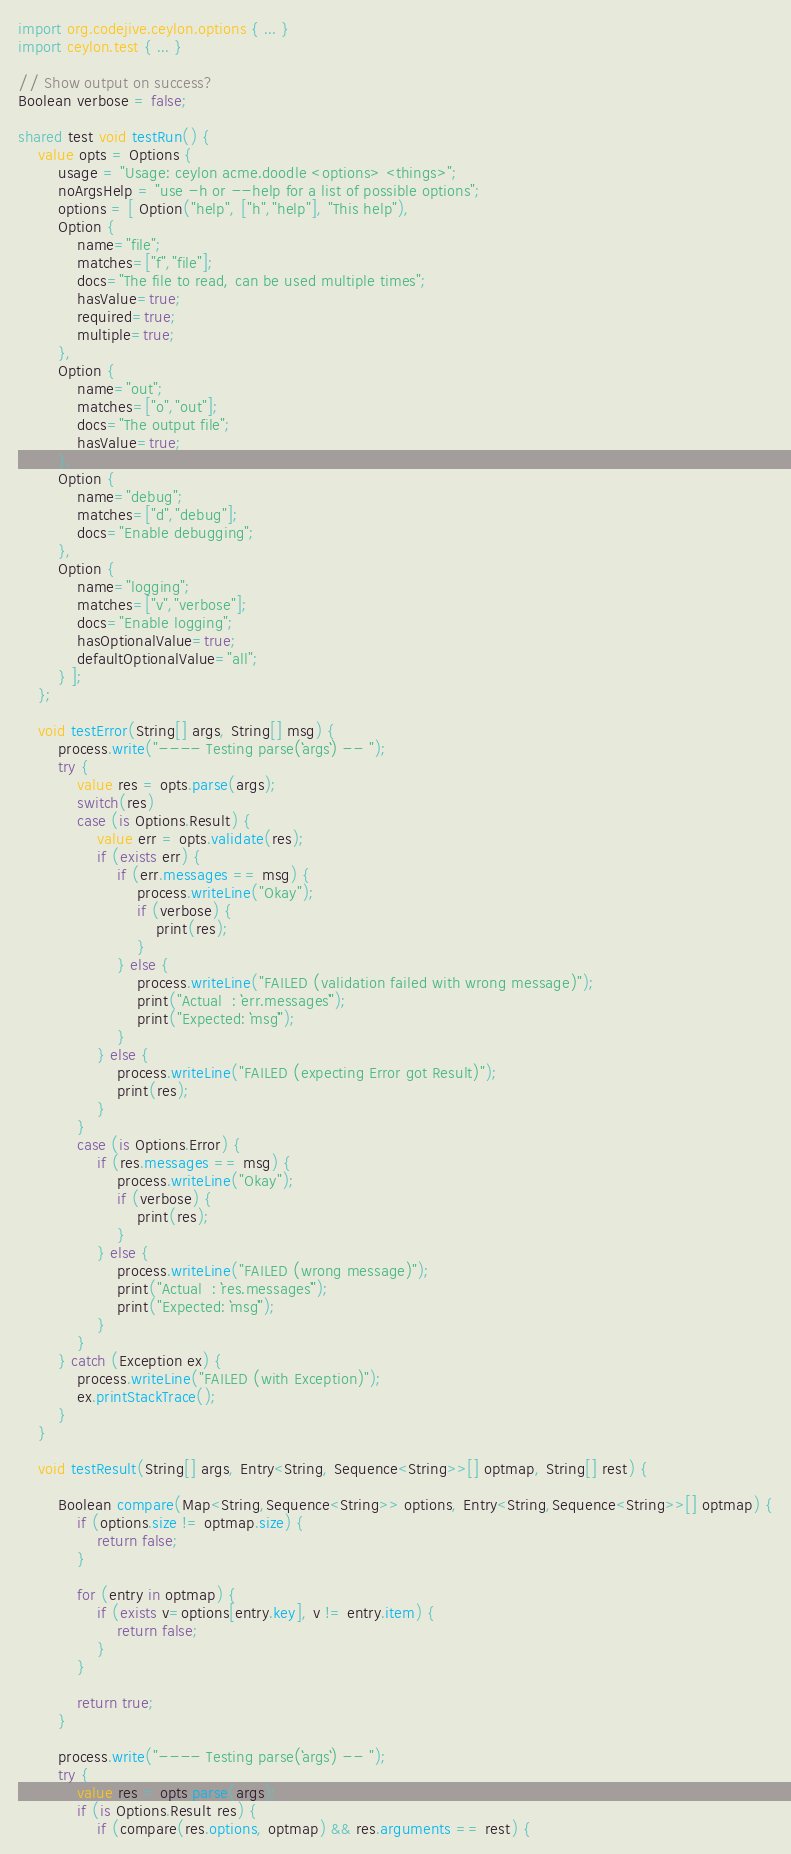<code> <loc_0><loc_0><loc_500><loc_500><_Ceylon_>
import org.codejive.ceylon.options { ... }
import ceylon.test { ... }

// Show output on success?
Boolean verbose = false;

shared test void testRun() {
    value opts = Options {
        usage = "Usage: ceylon acme.doodle <options> <things>";
        noArgsHelp = "use -h or --help for a list of possible options";
        options = [ Option("help", ["h","help"], "This help"),
        Option {
            name="file";
            matches=["f","file"];
            docs="The file to read, can be used multiple times";
            hasValue=true;
            required=true;
            multiple=true;
        },
        Option {
            name="out";
            matches=["o","out"];
            docs="The output file";
            hasValue=true;
        },
        Option {
            name="debug";
            matches=["d","debug"];
            docs="Enable debugging";
        },
        Option {
            name="logging";
            matches=["v","verbose"];
            docs="Enable logging";
            hasOptionalValue=true;
            defaultOptionalValue="all";
        } ];
    };

    void testError(String[] args, String[] msg) {
        process.write("---- Testing parse(``args``) -- ");
        try {
            value res = opts.parse(args);
            switch(res)
            case (is Options.Result) {
                value err = opts.validate(res);
                if (exists err) {
                    if (err.messages == msg) {
                        process.writeLine("Okay");
                        if (verbose) {
                            print(res);
                        }
                    } else {
                        process.writeLine("FAILED (validation failed with wrong message)");
                        print("Actual  : ``err.messages``");
                        print("Expected: ``msg``");
                    }
                } else {
                    process.writeLine("FAILED (expecting Error got Result)");
                    print(res);
                }
            }
            case (is Options.Error) {
                if (res.messages == msg) {
                    process.writeLine("Okay");
                    if (verbose) {
                        print(res);
                    }
                } else {
                    process.writeLine("FAILED (wrong message)");
                    print("Actual  : ``res.messages``");
                    print("Expected: ``msg``");
                }
            }
        } catch (Exception ex) {
            process.writeLine("FAILED (with Exception)");
            ex.printStackTrace();
        }
    }
    
    void testResult(String[] args, Entry<String, Sequence<String>>[] optmap, String[] rest) {

        Boolean compare(Map<String,Sequence<String>> options, Entry<String,Sequence<String>>[] optmap) {
            if (options.size != optmap.size) {
                return false;
            }
            
            for (entry in optmap) {
                if (exists v=options[entry.key], v != entry.item) {
                    return false;
                } 
            }
            
            return true;
        }
    
        process.write("---- Testing parse(``args``) -- ");
        try {
            value res = opts.parse(args);
            if (is Options.Result res) {
                if (compare(res.options, optmap) && res.arguments == rest) {</code> 